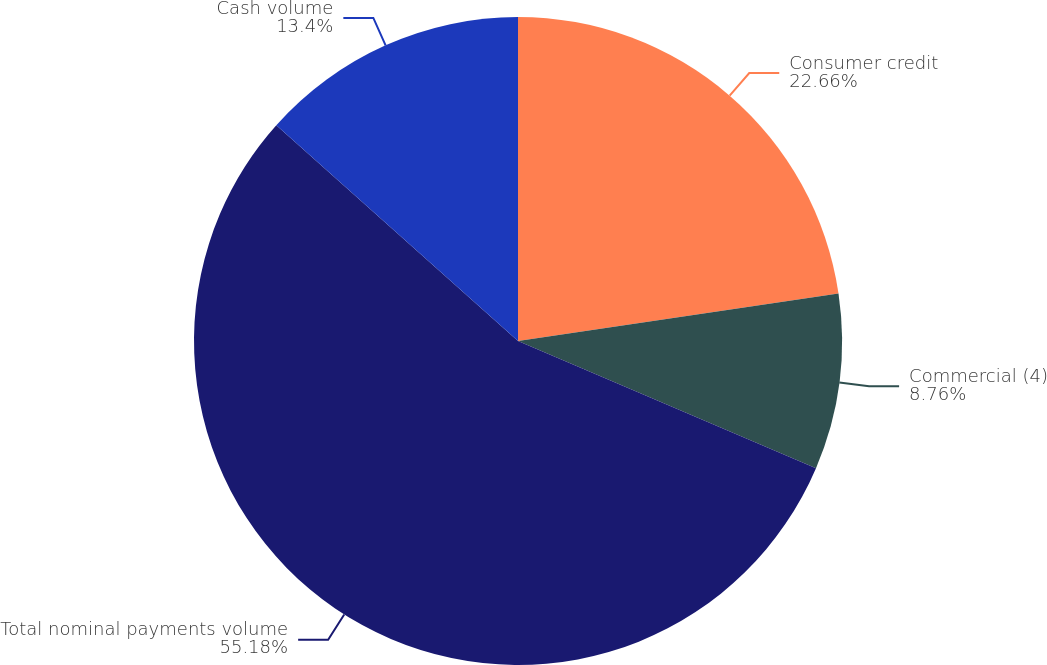Convert chart to OTSL. <chart><loc_0><loc_0><loc_500><loc_500><pie_chart><fcel>Consumer credit<fcel>Commercial (4)<fcel>Total nominal payments volume<fcel>Cash volume<nl><fcel>22.66%<fcel>8.76%<fcel>55.18%<fcel>13.4%<nl></chart> 